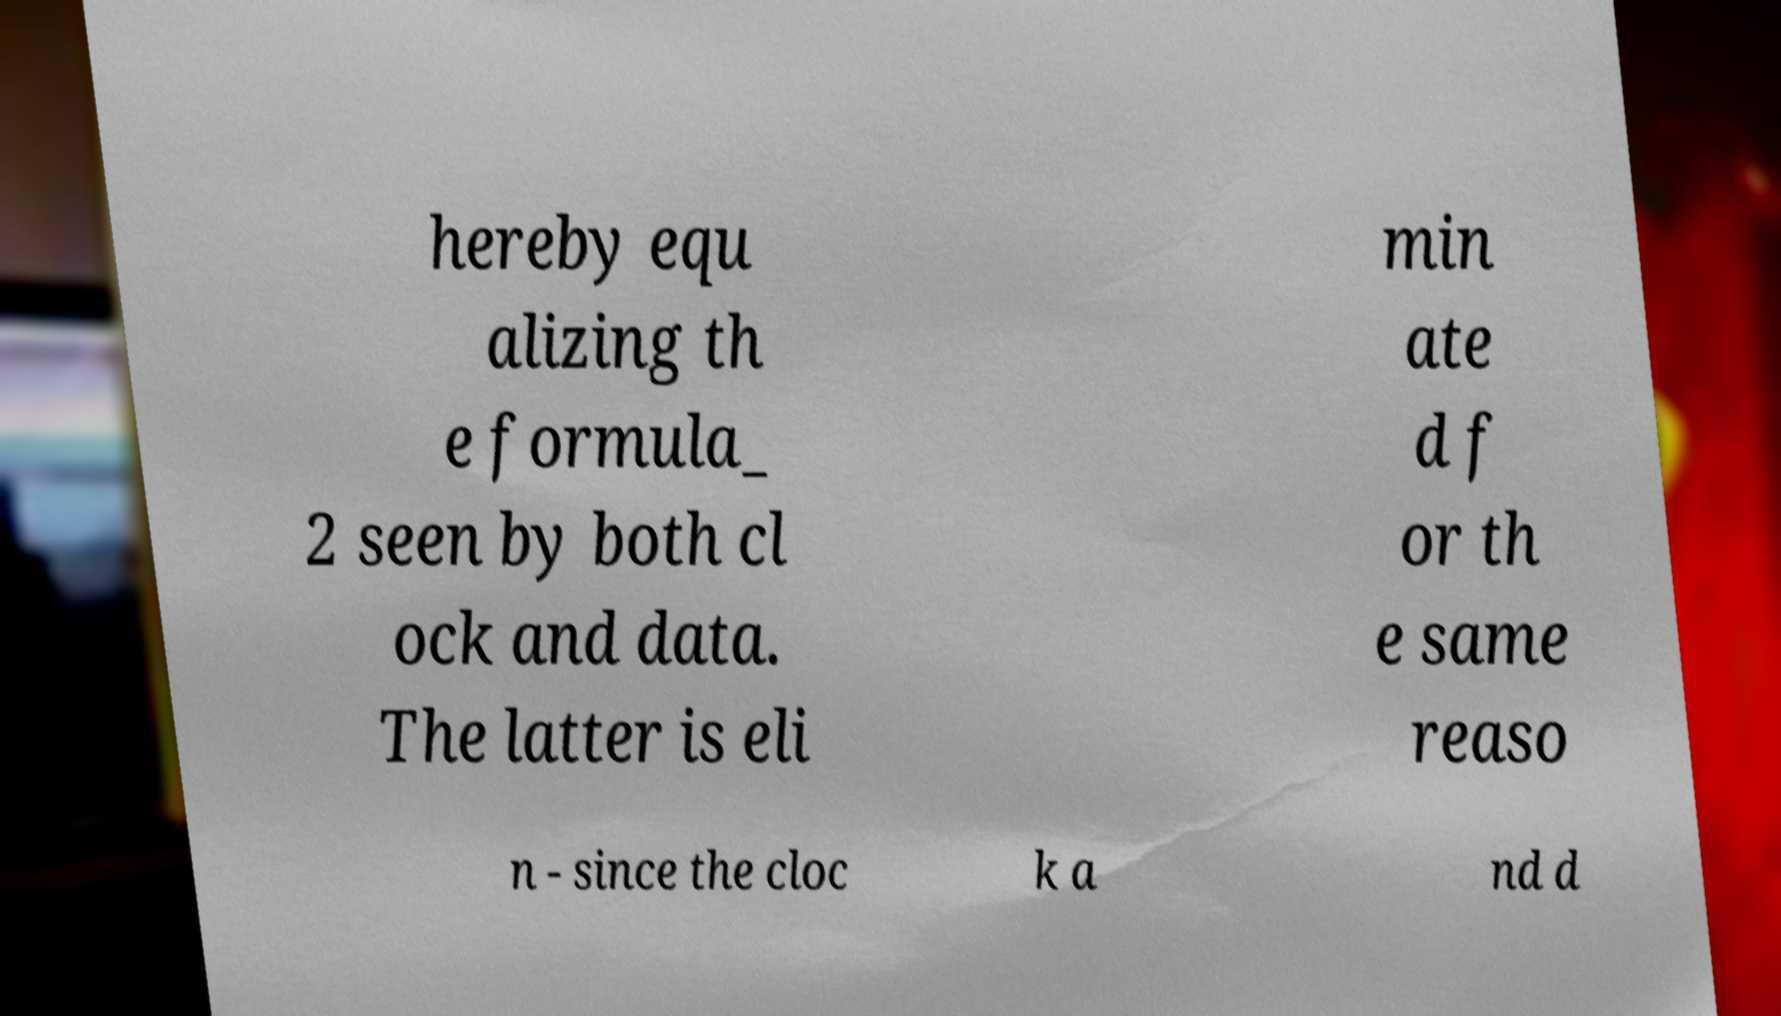There's text embedded in this image that I need extracted. Can you transcribe it verbatim? hereby equ alizing th e formula_ 2 seen by both cl ock and data. The latter is eli min ate d f or th e same reaso n - since the cloc k a nd d 